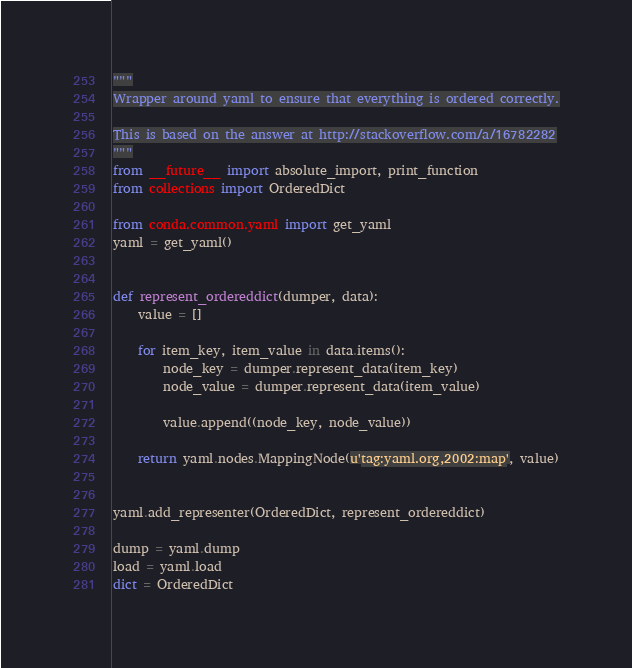<code> <loc_0><loc_0><loc_500><loc_500><_Python_>"""
Wrapper around yaml to ensure that everything is ordered correctly.

This is based on the answer at http://stackoverflow.com/a/16782282
"""
from __future__ import absolute_import, print_function
from collections import OrderedDict

from conda.common.yaml import get_yaml
yaml = get_yaml()


def represent_ordereddict(dumper, data):
    value = []

    for item_key, item_value in data.items():
        node_key = dumper.represent_data(item_key)
        node_value = dumper.represent_data(item_value)

        value.append((node_key, node_value))

    return yaml.nodes.MappingNode(u'tag:yaml.org,2002:map', value)


yaml.add_representer(OrderedDict, represent_ordereddict)

dump = yaml.dump
load = yaml.load
dict = OrderedDict
</code> 